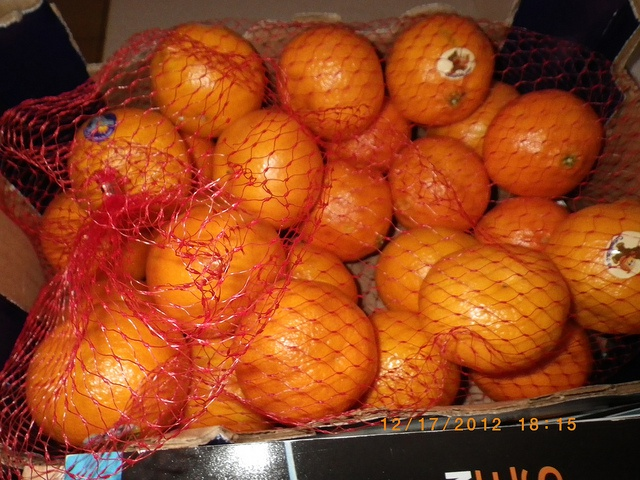Describe the objects in this image and their specific colors. I can see orange in gray, red, brown, and maroon tones, orange in gray, brown, red, and orange tones, orange in gray, red, orange, and brown tones, orange in gray, red, orange, and brown tones, and orange in gray, red, orange, and brown tones in this image. 